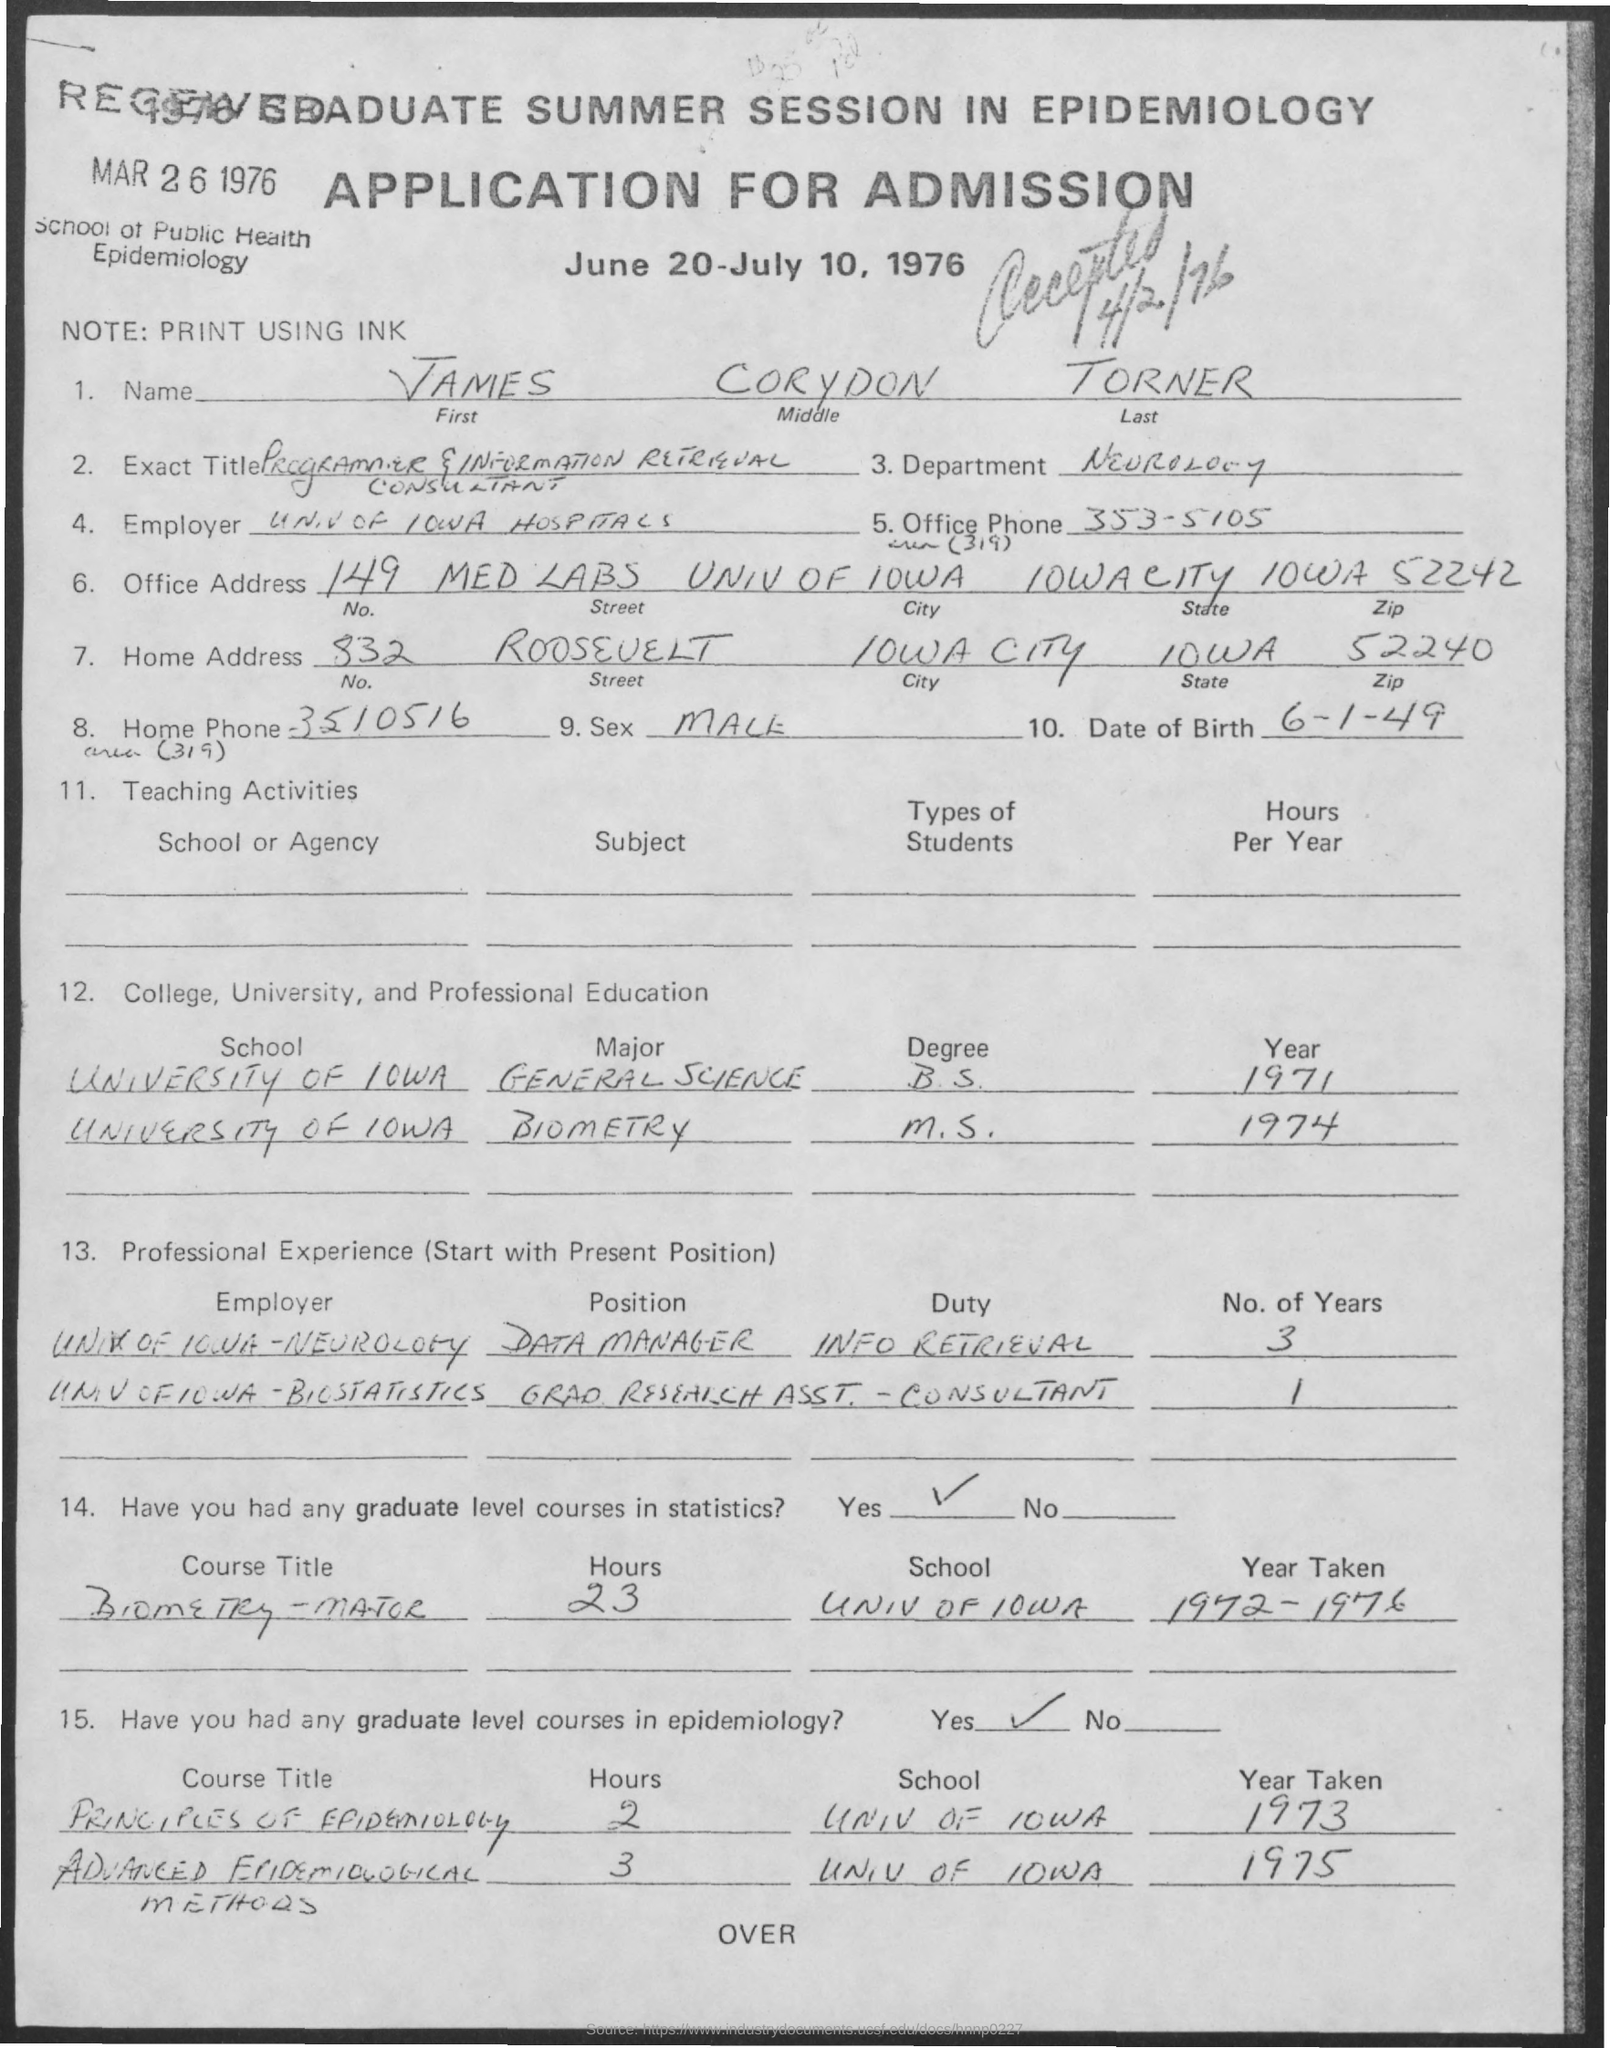What is the document about?
Offer a terse response. APPLICATION FOR ADMISSION. When is the document dated?
Your response must be concise. MAR 26 1976. What is the name given?
Provide a succinct answer. JAMES CORYDON TORNER. 